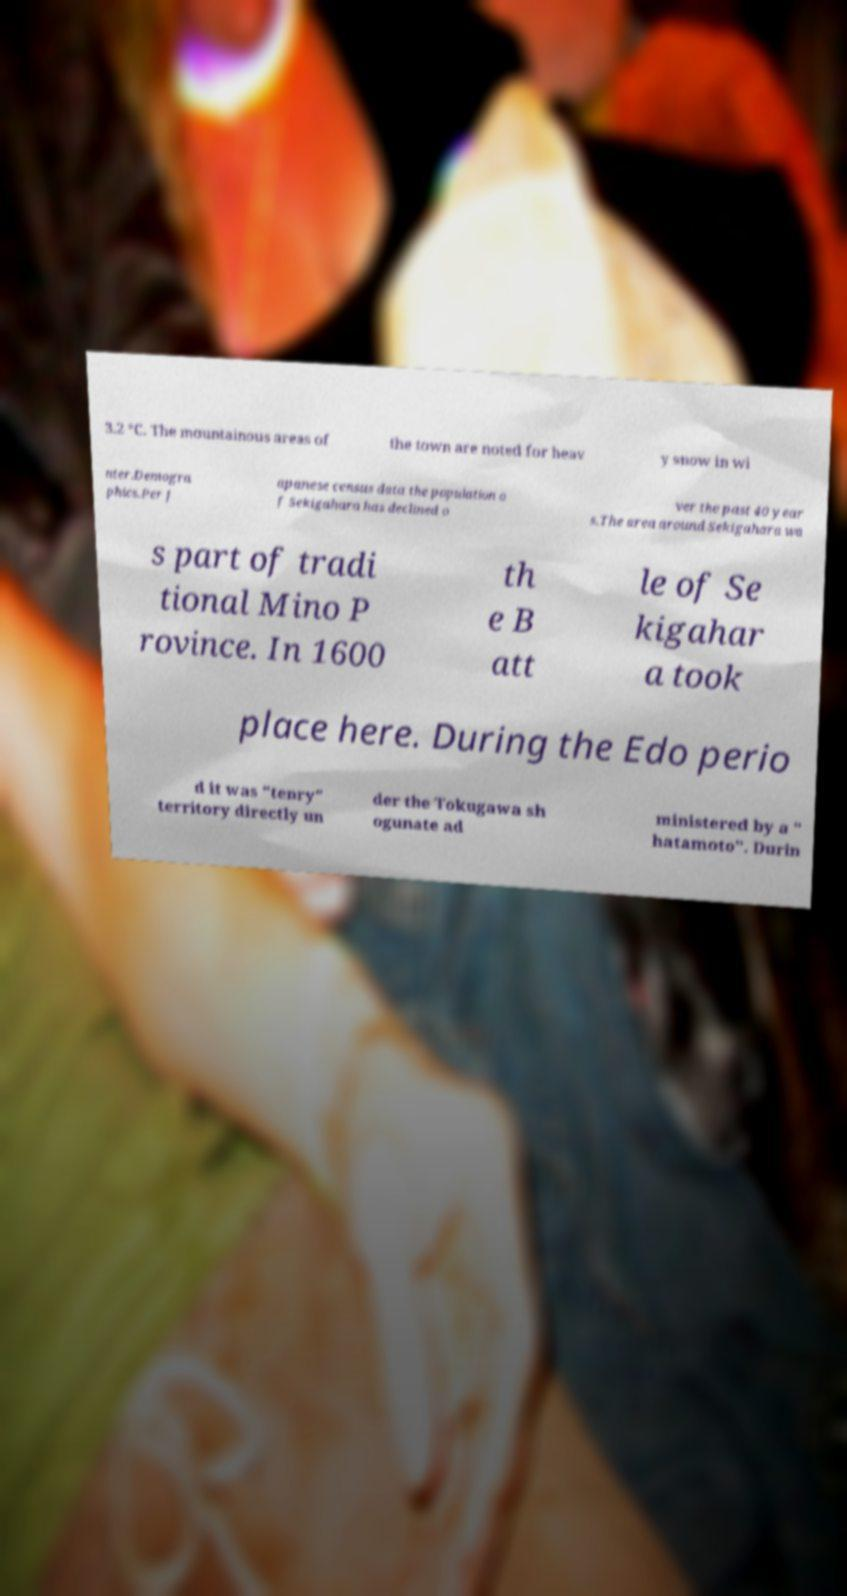Could you assist in decoding the text presented in this image and type it out clearly? 3.2 °C. The mountainous areas of the town are noted for heav y snow in wi nter.Demogra phics.Per J apanese census data the population o f Sekigahara has declined o ver the past 40 year s.The area around Sekigahara wa s part of tradi tional Mino P rovince. In 1600 th e B att le of Se kigahar a took place here. During the Edo perio d it was "tenry" territory directly un der the Tokugawa sh ogunate ad ministered by a " hatamoto". Durin 